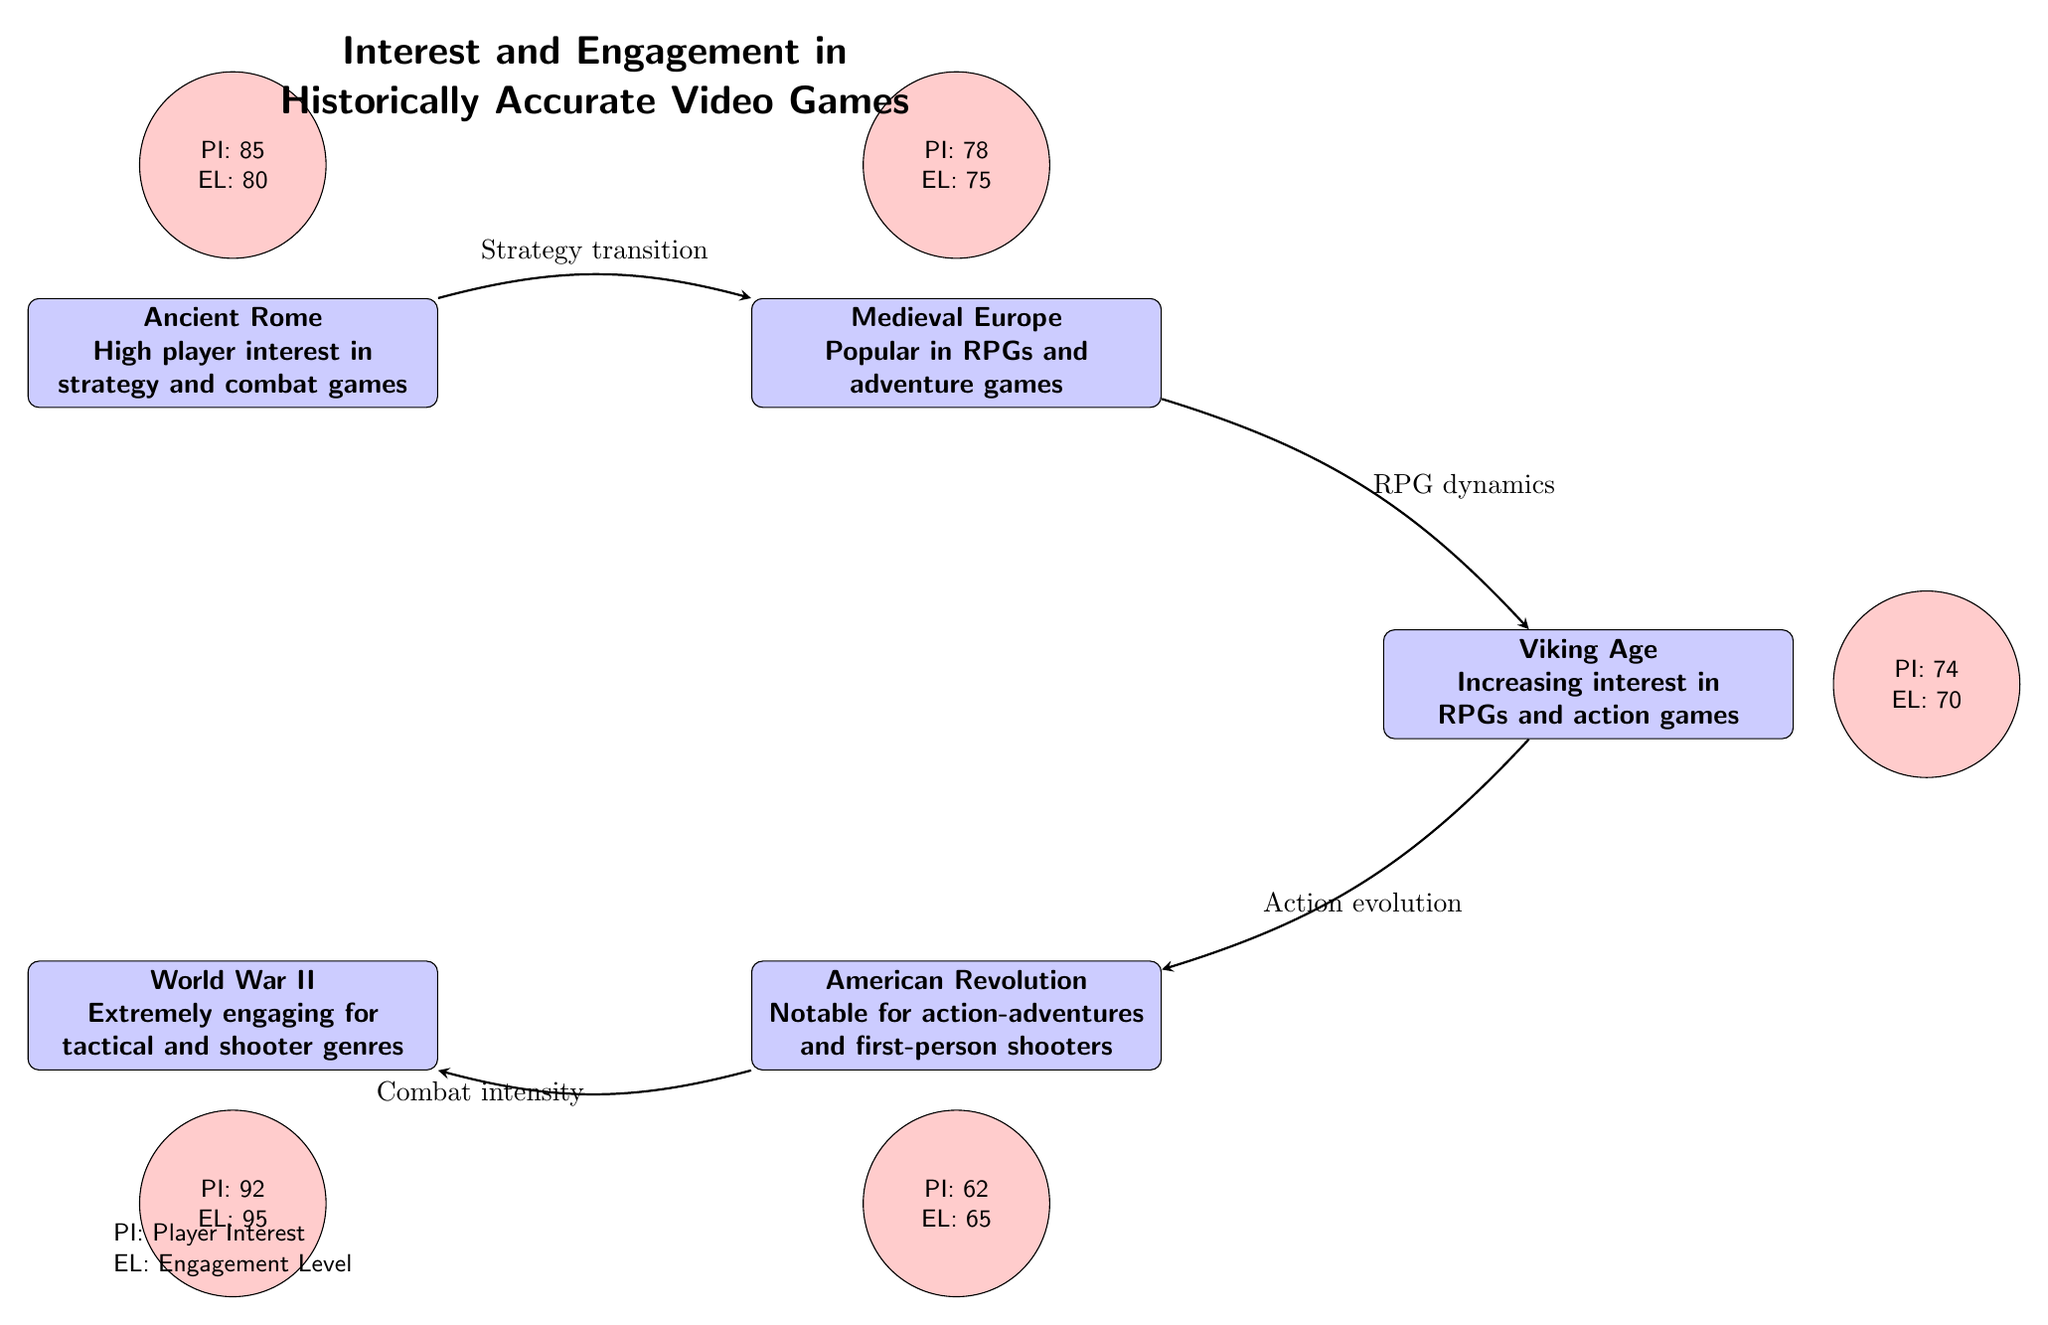What historical event has the highest player interest (PI)? In the diagram, the value for Player Interest (PI) is highest for World War II, which is indicated as 92.
Answer: World War II Which historical period is linked to Medieval Europe? The diagram shows an arrow from Ancient Rome to Medieval Europe, indicating a relationship between these two events.
Answer: Ancient Rome What is the engagement level (EL) of the Viking Age? The diagram states that the Engagement Level (EL) for the Viking Age is 70, as shown in the respective metric node.
Answer: 70 How many historical events are depicted in the diagram? The diagram clearly has five rectangular nodes, each representing a different historical event.
Answer: 5 Which event has the lowest engagement level (EL)? By looking at the Engagement Levels (EL) grouped by historical event, the lowest level (65) corresponds to the American Revolution.
Answer: American Revolution What is the transition type between Medieval Europe and the Viking Age? The diagram specifies the transition from Medieval Europe to the Viking Age labeled as "RPG dynamics" along the arrow connecting them.
Answer: RPG dynamics What is the player interest (PI) for Ancient Rome? The diagram shows that the Player Interest (PI) for Ancient Rome is 85, indicated in the respective metric node above it.
Answer: 85 Which historical event has a combat intensity connection? According to the diagram, the relationship described as "Combat intensity" connects the American Revolution to World War II.
Answer: American Revolution What color indicates engagement level (EL) in the diagram? The engagement metric is represented by a red circle filled with color, indicating the engagement level for each historical event.
Answer: Red 